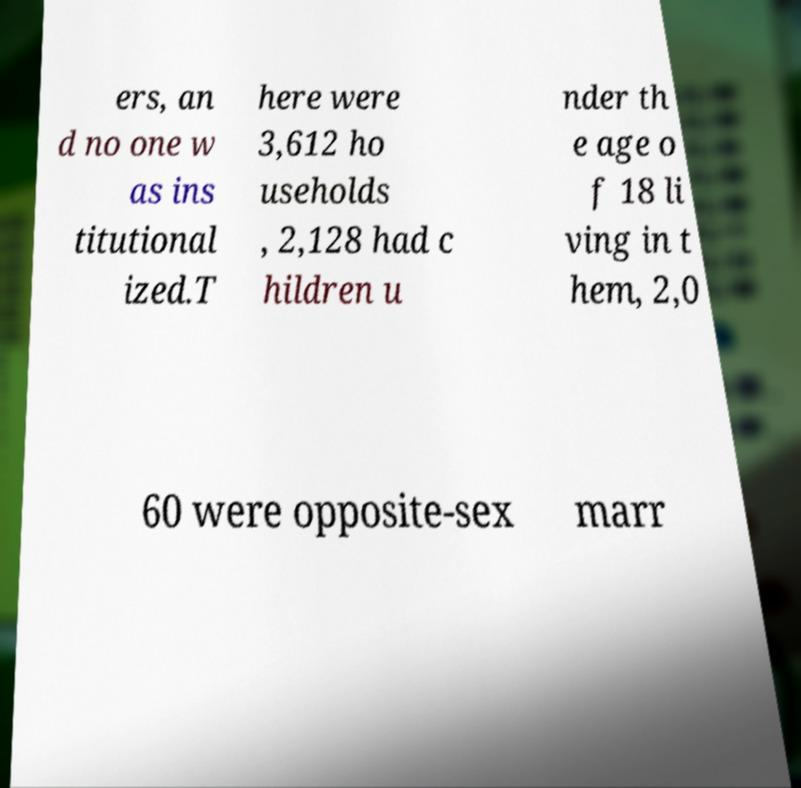Please read and relay the text visible in this image. What does it say? ers, an d no one w as ins titutional ized.T here were 3,612 ho useholds , 2,128 had c hildren u nder th e age o f 18 li ving in t hem, 2,0 60 were opposite-sex marr 